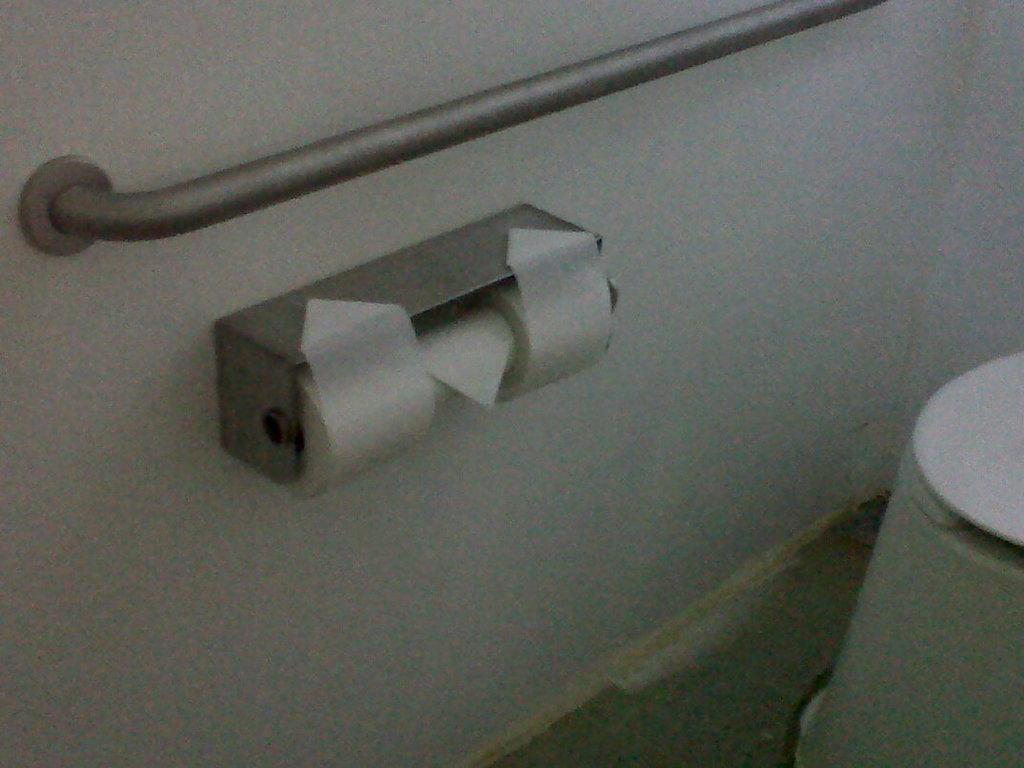Could you give a brief overview of what you see in this image? In this image we can see a wall, on the wall there is a hanger rod and a tissue roll, also we can see another object on the surface. 